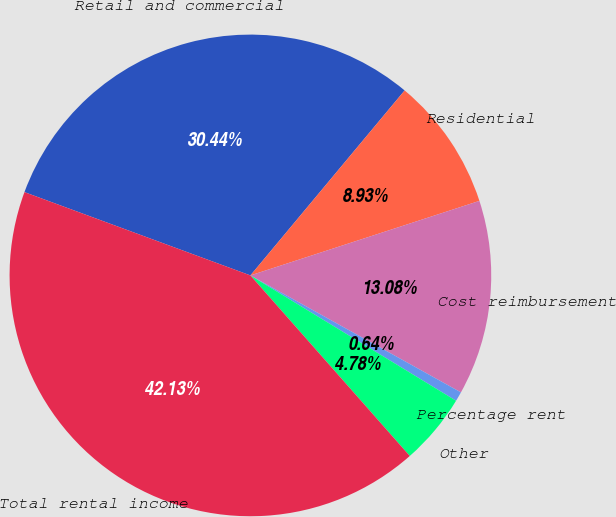Convert chart to OTSL. <chart><loc_0><loc_0><loc_500><loc_500><pie_chart><fcel>Retail and commercial<fcel>Residential<fcel>Cost reimbursement<fcel>Percentage rent<fcel>Other<fcel>Total rental income<nl><fcel>30.44%<fcel>8.93%<fcel>13.08%<fcel>0.64%<fcel>4.78%<fcel>42.13%<nl></chart> 